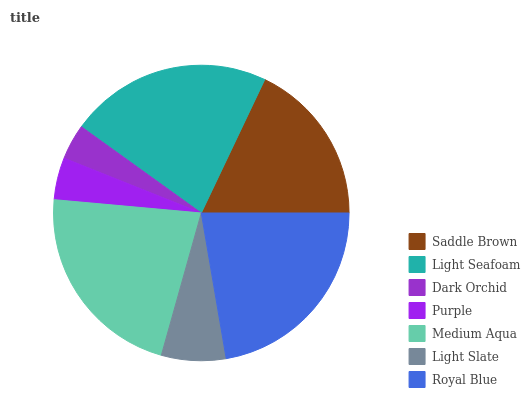Is Dark Orchid the minimum?
Answer yes or no. Yes. Is Royal Blue the maximum?
Answer yes or no. Yes. Is Light Seafoam the minimum?
Answer yes or no. No. Is Light Seafoam the maximum?
Answer yes or no. No. Is Light Seafoam greater than Saddle Brown?
Answer yes or no. Yes. Is Saddle Brown less than Light Seafoam?
Answer yes or no. Yes. Is Saddle Brown greater than Light Seafoam?
Answer yes or no. No. Is Light Seafoam less than Saddle Brown?
Answer yes or no. No. Is Saddle Brown the high median?
Answer yes or no. Yes. Is Saddle Brown the low median?
Answer yes or no. Yes. Is Purple the high median?
Answer yes or no. No. Is Royal Blue the low median?
Answer yes or no. No. 